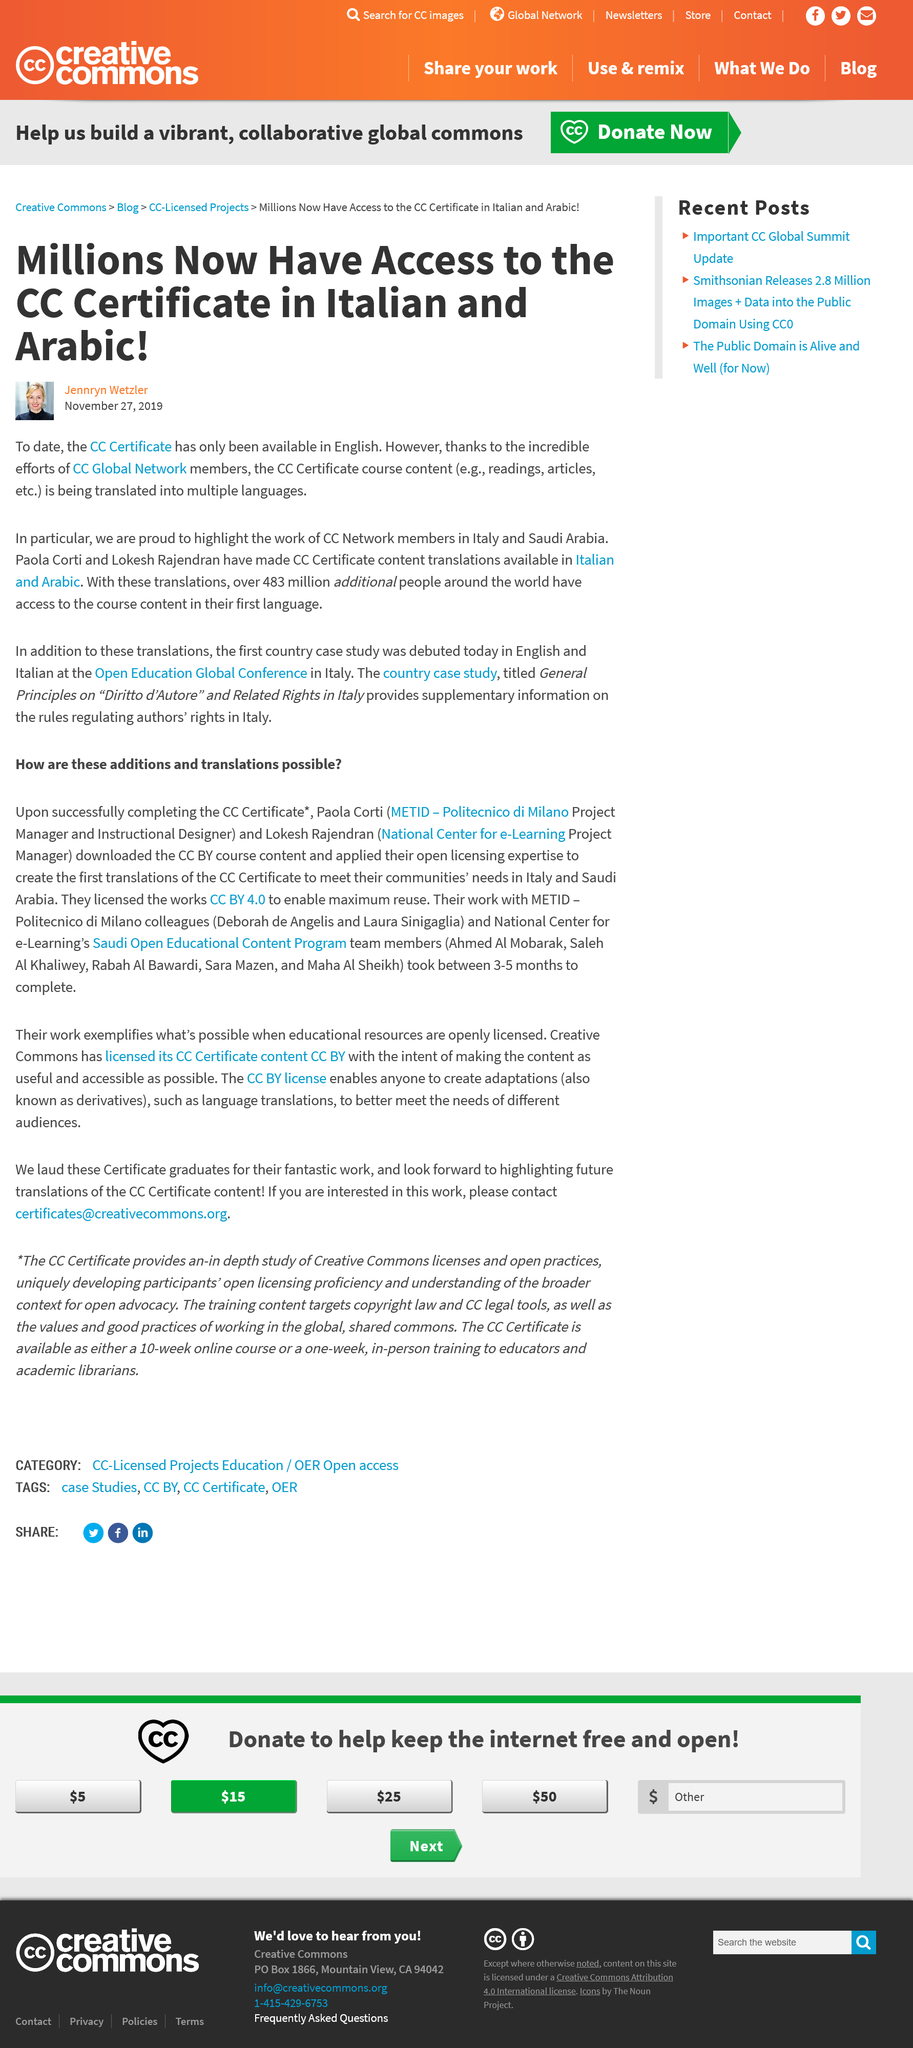Point out several critical features in this image. The CC certificate for Italian and Arabic languages has been made available. Until now, the CC certificate has only been available in English. The course content is accessible to an additional 483 million people in their first language. 